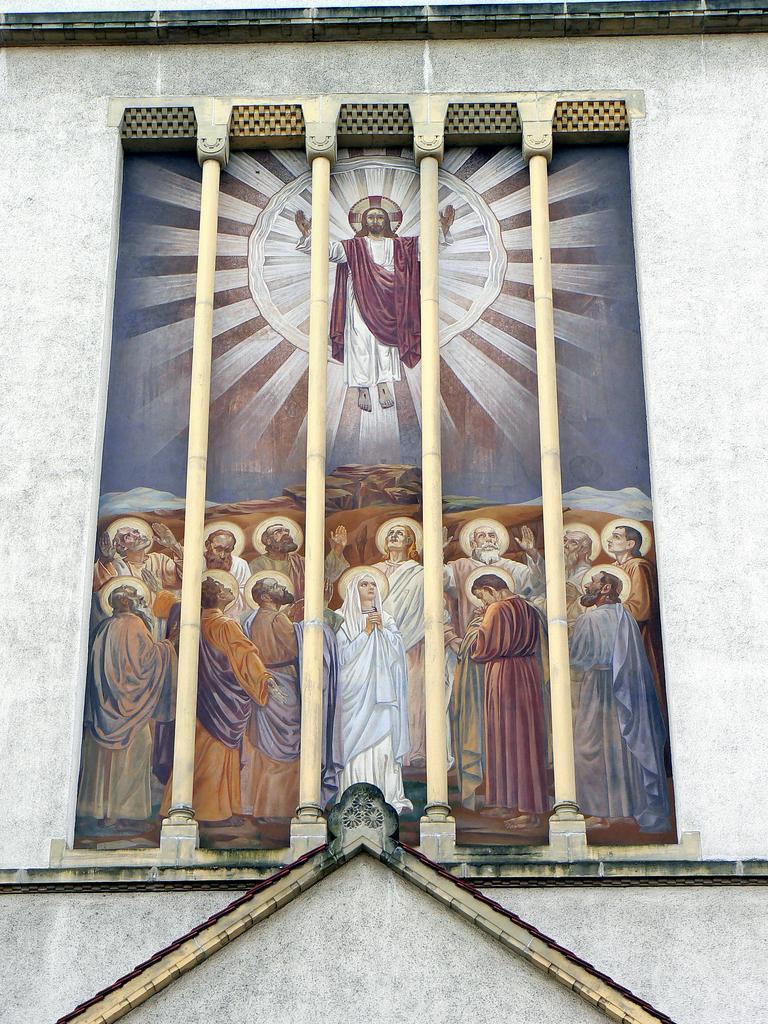Can you describe this image briefly? In this image there on the wall there is a painting of Jesus Christ and his disciples, on the wall there are pillars. 